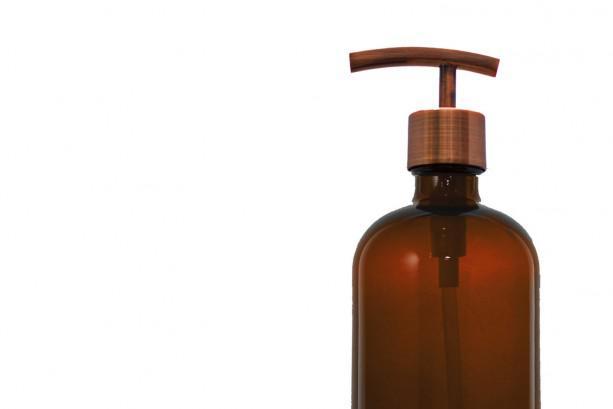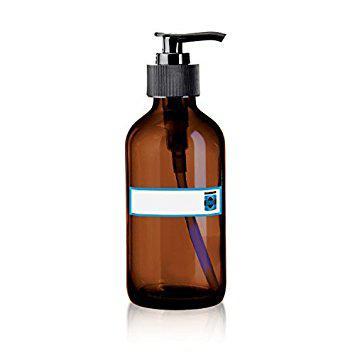The first image is the image on the left, the second image is the image on the right. Evaluate the accuracy of this statement regarding the images: "The nozzle of the dispenser in the right image is pointed towards the right.". Is it true? Answer yes or no. Yes. The first image is the image on the left, the second image is the image on the right. Assess this claim about the two images: "There is a plant to the left of one of the bottles, and one of the bottles is on a wooden surface.". Correct or not? Answer yes or no. No. 